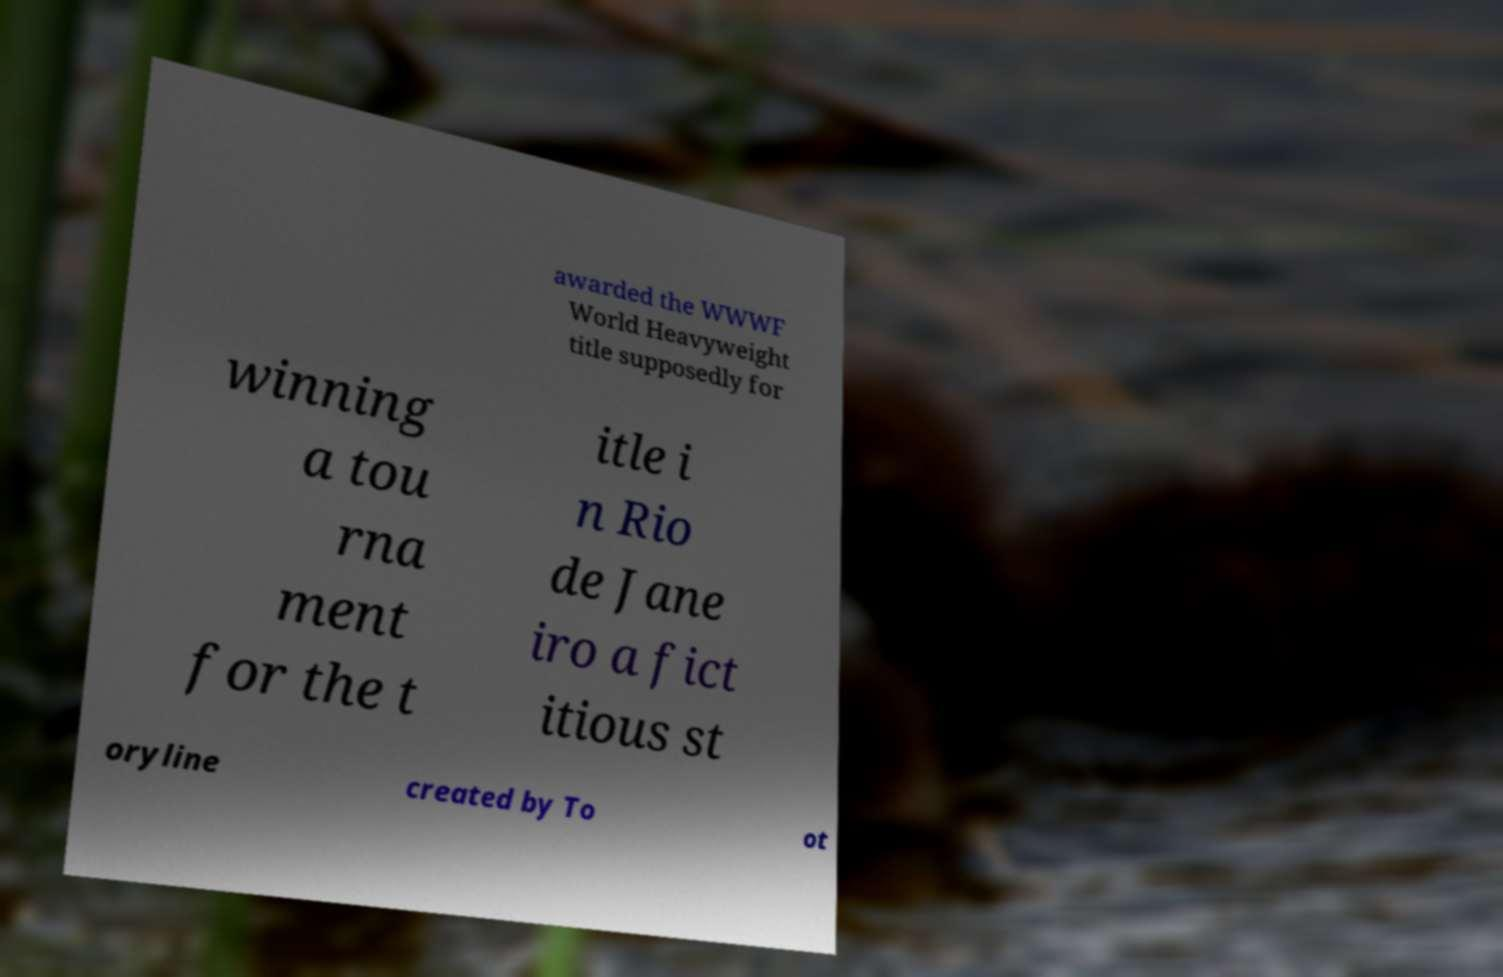There's text embedded in this image that I need extracted. Can you transcribe it verbatim? awarded the WWWF World Heavyweight title supposedly for winning a tou rna ment for the t itle i n Rio de Jane iro a fict itious st oryline created by To ot 